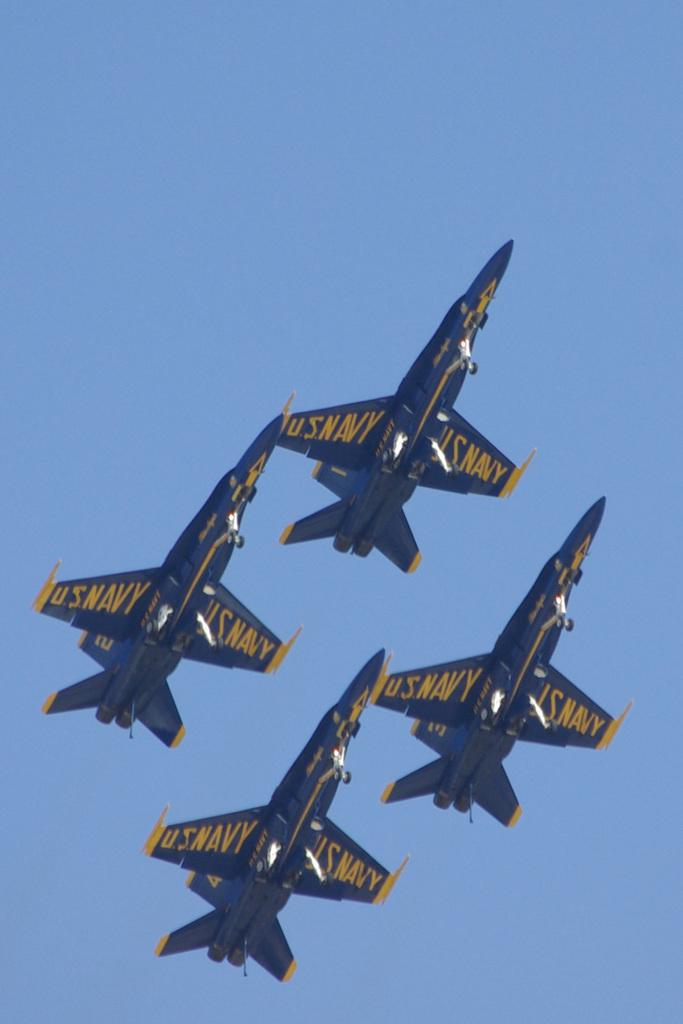<image>
Summarize the visual content of the image. 4 US navy planes are flying in formation. 